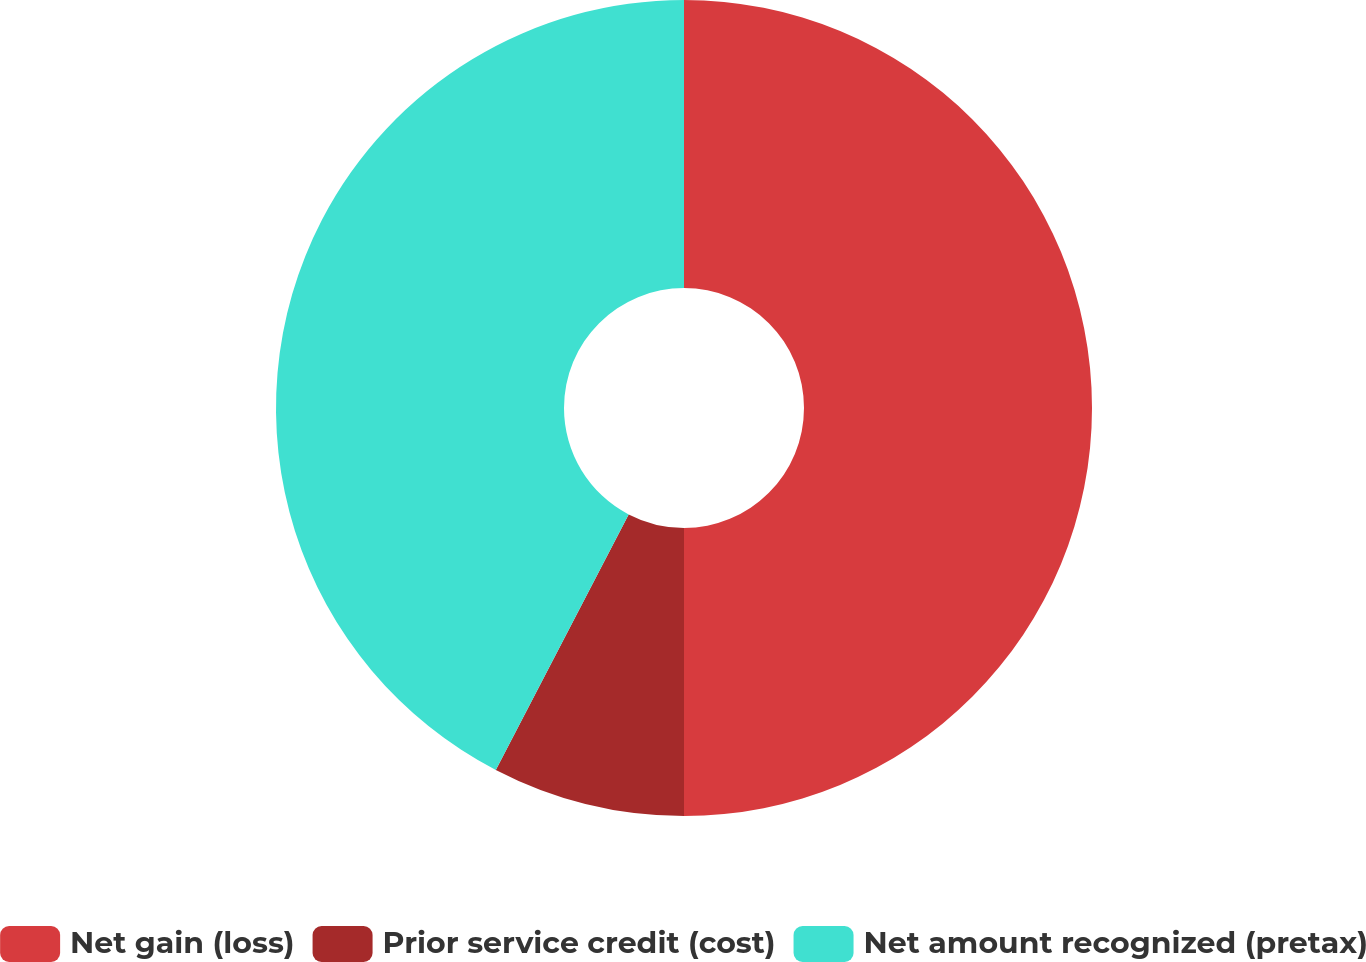Convert chart to OTSL. <chart><loc_0><loc_0><loc_500><loc_500><pie_chart><fcel>Net gain (loss)<fcel>Prior service credit (cost)<fcel>Net amount recognized (pretax)<nl><fcel>50.0%<fcel>7.63%<fcel>42.37%<nl></chart> 